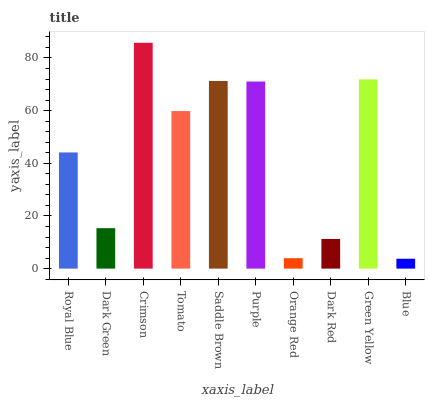Is Dark Green the minimum?
Answer yes or no. No. Is Dark Green the maximum?
Answer yes or no. No. Is Royal Blue greater than Dark Green?
Answer yes or no. Yes. Is Dark Green less than Royal Blue?
Answer yes or no. Yes. Is Dark Green greater than Royal Blue?
Answer yes or no. No. Is Royal Blue less than Dark Green?
Answer yes or no. No. Is Tomato the high median?
Answer yes or no. Yes. Is Royal Blue the low median?
Answer yes or no. Yes. Is Purple the high median?
Answer yes or no. No. Is Dark Red the low median?
Answer yes or no. No. 